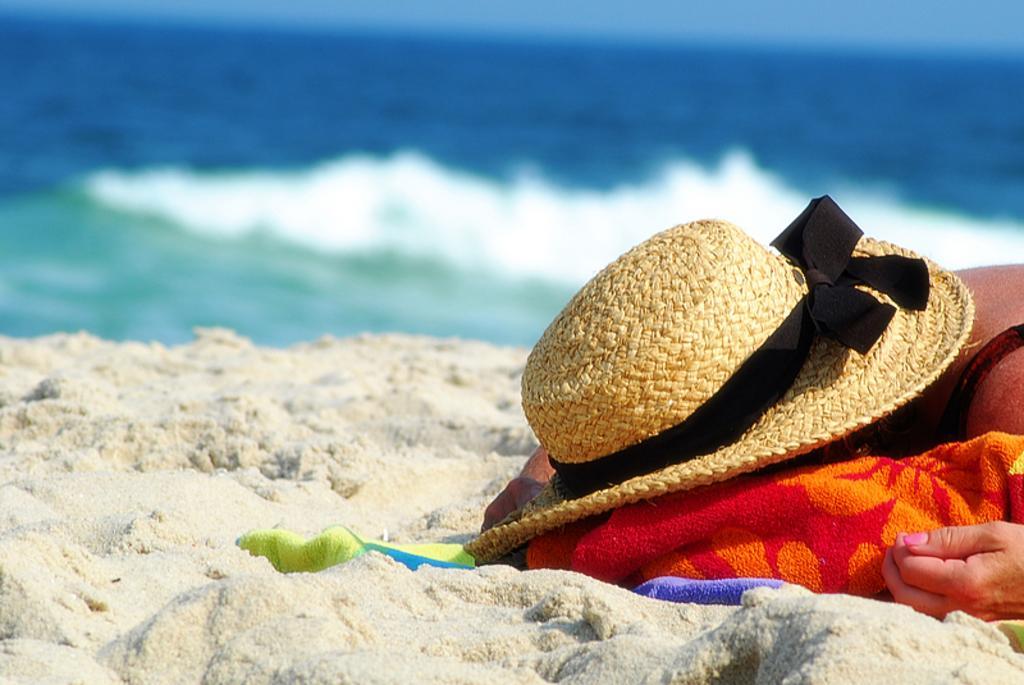Describe this image in one or two sentences. In this picture there is a person with hat and we can see a cloth on sand. In the background of the image we can see water. 